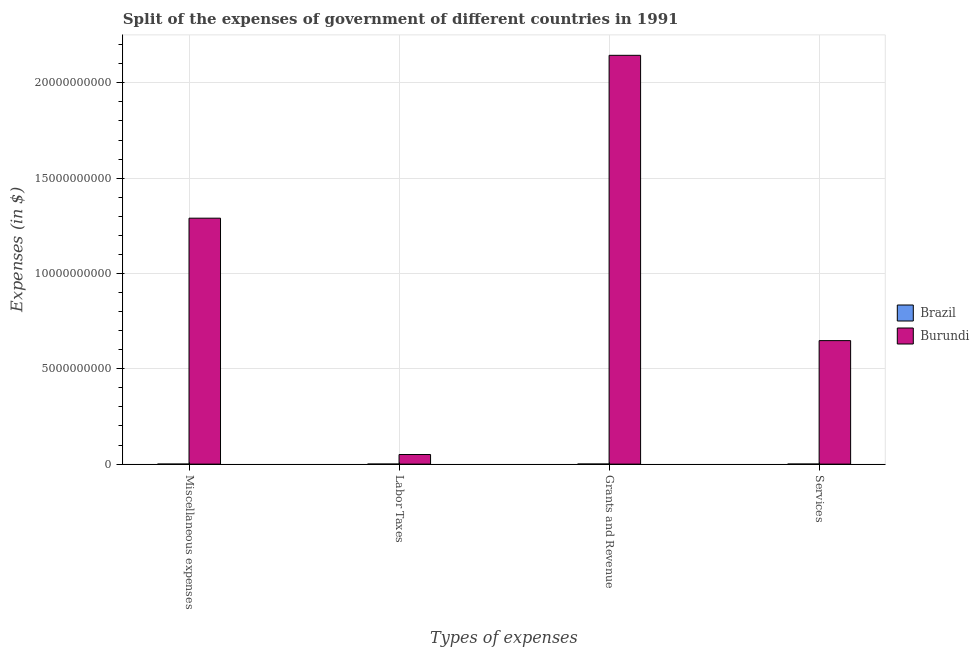How many groups of bars are there?
Your response must be concise. 4. How many bars are there on the 4th tick from the right?
Give a very brief answer. 2. What is the label of the 4th group of bars from the left?
Ensure brevity in your answer.  Services. What is the amount spent on labor taxes in Brazil?
Offer a terse response. 6.33e+05. Across all countries, what is the maximum amount spent on miscellaneous expenses?
Your response must be concise. 1.29e+1. Across all countries, what is the minimum amount spent on labor taxes?
Give a very brief answer. 6.33e+05. In which country was the amount spent on labor taxes maximum?
Your answer should be compact. Burundi. What is the total amount spent on labor taxes in the graph?
Offer a terse response. 5.04e+08. What is the difference between the amount spent on miscellaneous expenses in Brazil and that in Burundi?
Keep it short and to the point. -1.29e+1. What is the difference between the amount spent on services in Brazil and the amount spent on labor taxes in Burundi?
Keep it short and to the point. -5.02e+08. What is the average amount spent on miscellaneous expenses per country?
Your answer should be compact. 6.45e+09. What is the difference between the amount spent on services and amount spent on labor taxes in Burundi?
Your response must be concise. 5.98e+09. In how many countries, is the amount spent on labor taxes greater than 18000000000 $?
Your answer should be compact. 0. What is the ratio of the amount spent on miscellaneous expenses in Burundi to that in Brazil?
Provide a short and direct response. 1.01e+05. Is the amount spent on miscellaneous expenses in Brazil less than that in Burundi?
Give a very brief answer. Yes. Is the difference between the amount spent on services in Burundi and Brazil greater than the difference between the amount spent on grants and revenue in Burundi and Brazil?
Offer a very short reply. No. What is the difference between the highest and the second highest amount spent on miscellaneous expenses?
Provide a short and direct response. 1.29e+1. What is the difference between the highest and the lowest amount spent on miscellaneous expenses?
Your answer should be very brief. 1.29e+1. In how many countries, is the amount spent on grants and revenue greater than the average amount spent on grants and revenue taken over all countries?
Ensure brevity in your answer.  1. What does the 2nd bar from the left in Labor Taxes represents?
Offer a terse response. Burundi. What does the 2nd bar from the right in Grants and Revenue represents?
Give a very brief answer. Brazil. Is it the case that in every country, the sum of the amount spent on miscellaneous expenses and amount spent on labor taxes is greater than the amount spent on grants and revenue?
Offer a very short reply. No. How many bars are there?
Give a very brief answer. 8. Are all the bars in the graph horizontal?
Offer a terse response. No. Does the graph contain any zero values?
Give a very brief answer. No. Does the graph contain grids?
Make the answer very short. Yes. How many legend labels are there?
Make the answer very short. 2. How are the legend labels stacked?
Provide a short and direct response. Vertical. What is the title of the graph?
Keep it short and to the point. Split of the expenses of government of different countries in 1991. What is the label or title of the X-axis?
Offer a terse response. Types of expenses. What is the label or title of the Y-axis?
Make the answer very short. Expenses (in $). What is the Expenses (in $) in Brazil in Miscellaneous expenses?
Your answer should be very brief. 1.27e+05. What is the Expenses (in $) of Burundi in Miscellaneous expenses?
Offer a terse response. 1.29e+1. What is the Expenses (in $) of Brazil in Labor Taxes?
Offer a very short reply. 6.33e+05. What is the Expenses (in $) in Burundi in Labor Taxes?
Give a very brief answer. 5.03e+08. What is the Expenses (in $) of Brazil in Grants and Revenue?
Your answer should be very brief. 3.07e+06. What is the Expenses (in $) of Burundi in Grants and Revenue?
Make the answer very short. 2.14e+1. What is the Expenses (in $) in Brazil in Services?
Your response must be concise. 1.38e+06. What is the Expenses (in $) of Burundi in Services?
Give a very brief answer. 6.48e+09. Across all Types of expenses, what is the maximum Expenses (in $) of Brazil?
Your response must be concise. 3.07e+06. Across all Types of expenses, what is the maximum Expenses (in $) of Burundi?
Keep it short and to the point. 2.14e+1. Across all Types of expenses, what is the minimum Expenses (in $) in Brazil?
Keep it short and to the point. 1.27e+05. Across all Types of expenses, what is the minimum Expenses (in $) in Burundi?
Make the answer very short. 5.03e+08. What is the total Expenses (in $) of Brazil in the graph?
Provide a short and direct response. 5.21e+06. What is the total Expenses (in $) of Burundi in the graph?
Your response must be concise. 4.13e+1. What is the difference between the Expenses (in $) of Brazil in Miscellaneous expenses and that in Labor Taxes?
Offer a terse response. -5.05e+05. What is the difference between the Expenses (in $) of Burundi in Miscellaneous expenses and that in Labor Taxes?
Your answer should be compact. 1.24e+1. What is the difference between the Expenses (in $) in Brazil in Miscellaneous expenses and that in Grants and Revenue?
Your response must be concise. -2.94e+06. What is the difference between the Expenses (in $) in Burundi in Miscellaneous expenses and that in Grants and Revenue?
Provide a succinct answer. -8.54e+09. What is the difference between the Expenses (in $) in Brazil in Miscellaneous expenses and that in Services?
Your response must be concise. -1.26e+06. What is the difference between the Expenses (in $) in Burundi in Miscellaneous expenses and that in Services?
Your answer should be compact. 6.42e+09. What is the difference between the Expenses (in $) of Brazil in Labor Taxes and that in Grants and Revenue?
Make the answer very short. -2.43e+06. What is the difference between the Expenses (in $) in Burundi in Labor Taxes and that in Grants and Revenue?
Ensure brevity in your answer.  -2.09e+1. What is the difference between the Expenses (in $) of Brazil in Labor Taxes and that in Services?
Ensure brevity in your answer.  -7.51e+05. What is the difference between the Expenses (in $) in Burundi in Labor Taxes and that in Services?
Provide a short and direct response. -5.98e+09. What is the difference between the Expenses (in $) of Brazil in Grants and Revenue and that in Services?
Your answer should be compact. 1.68e+06. What is the difference between the Expenses (in $) of Burundi in Grants and Revenue and that in Services?
Provide a short and direct response. 1.50e+1. What is the difference between the Expenses (in $) of Brazil in Miscellaneous expenses and the Expenses (in $) of Burundi in Labor Taxes?
Your answer should be very brief. -5.03e+08. What is the difference between the Expenses (in $) of Brazil in Miscellaneous expenses and the Expenses (in $) of Burundi in Grants and Revenue?
Offer a very short reply. -2.14e+1. What is the difference between the Expenses (in $) of Brazil in Miscellaneous expenses and the Expenses (in $) of Burundi in Services?
Offer a very short reply. -6.48e+09. What is the difference between the Expenses (in $) in Brazil in Labor Taxes and the Expenses (in $) in Burundi in Grants and Revenue?
Your answer should be compact. -2.14e+1. What is the difference between the Expenses (in $) of Brazil in Labor Taxes and the Expenses (in $) of Burundi in Services?
Provide a succinct answer. -6.48e+09. What is the difference between the Expenses (in $) of Brazil in Grants and Revenue and the Expenses (in $) of Burundi in Services?
Offer a very short reply. -6.47e+09. What is the average Expenses (in $) of Brazil per Types of expenses?
Ensure brevity in your answer.  1.30e+06. What is the average Expenses (in $) of Burundi per Types of expenses?
Ensure brevity in your answer.  1.03e+1. What is the difference between the Expenses (in $) in Brazil and Expenses (in $) in Burundi in Miscellaneous expenses?
Your response must be concise. -1.29e+1. What is the difference between the Expenses (in $) in Brazil and Expenses (in $) in Burundi in Labor Taxes?
Offer a very short reply. -5.02e+08. What is the difference between the Expenses (in $) of Brazil and Expenses (in $) of Burundi in Grants and Revenue?
Offer a very short reply. -2.14e+1. What is the difference between the Expenses (in $) of Brazil and Expenses (in $) of Burundi in Services?
Keep it short and to the point. -6.48e+09. What is the ratio of the Expenses (in $) of Brazil in Miscellaneous expenses to that in Labor Taxes?
Keep it short and to the point. 0.2. What is the ratio of the Expenses (in $) in Burundi in Miscellaneous expenses to that in Labor Taxes?
Keep it short and to the point. 25.65. What is the ratio of the Expenses (in $) of Brazil in Miscellaneous expenses to that in Grants and Revenue?
Your answer should be compact. 0.04. What is the ratio of the Expenses (in $) in Burundi in Miscellaneous expenses to that in Grants and Revenue?
Your answer should be compact. 0.6. What is the ratio of the Expenses (in $) in Brazil in Miscellaneous expenses to that in Services?
Your answer should be compact. 0.09. What is the ratio of the Expenses (in $) in Burundi in Miscellaneous expenses to that in Services?
Offer a very short reply. 1.99. What is the ratio of the Expenses (in $) in Brazil in Labor Taxes to that in Grants and Revenue?
Provide a succinct answer. 0.21. What is the ratio of the Expenses (in $) of Burundi in Labor Taxes to that in Grants and Revenue?
Provide a short and direct response. 0.02. What is the ratio of the Expenses (in $) of Brazil in Labor Taxes to that in Services?
Your answer should be very brief. 0.46. What is the ratio of the Expenses (in $) of Burundi in Labor Taxes to that in Services?
Keep it short and to the point. 0.08. What is the ratio of the Expenses (in $) of Brazil in Grants and Revenue to that in Services?
Your answer should be compact. 2.22. What is the ratio of the Expenses (in $) in Burundi in Grants and Revenue to that in Services?
Keep it short and to the point. 3.31. What is the difference between the highest and the second highest Expenses (in $) of Brazil?
Provide a short and direct response. 1.68e+06. What is the difference between the highest and the second highest Expenses (in $) in Burundi?
Make the answer very short. 8.54e+09. What is the difference between the highest and the lowest Expenses (in $) of Brazil?
Provide a short and direct response. 2.94e+06. What is the difference between the highest and the lowest Expenses (in $) in Burundi?
Offer a very short reply. 2.09e+1. 